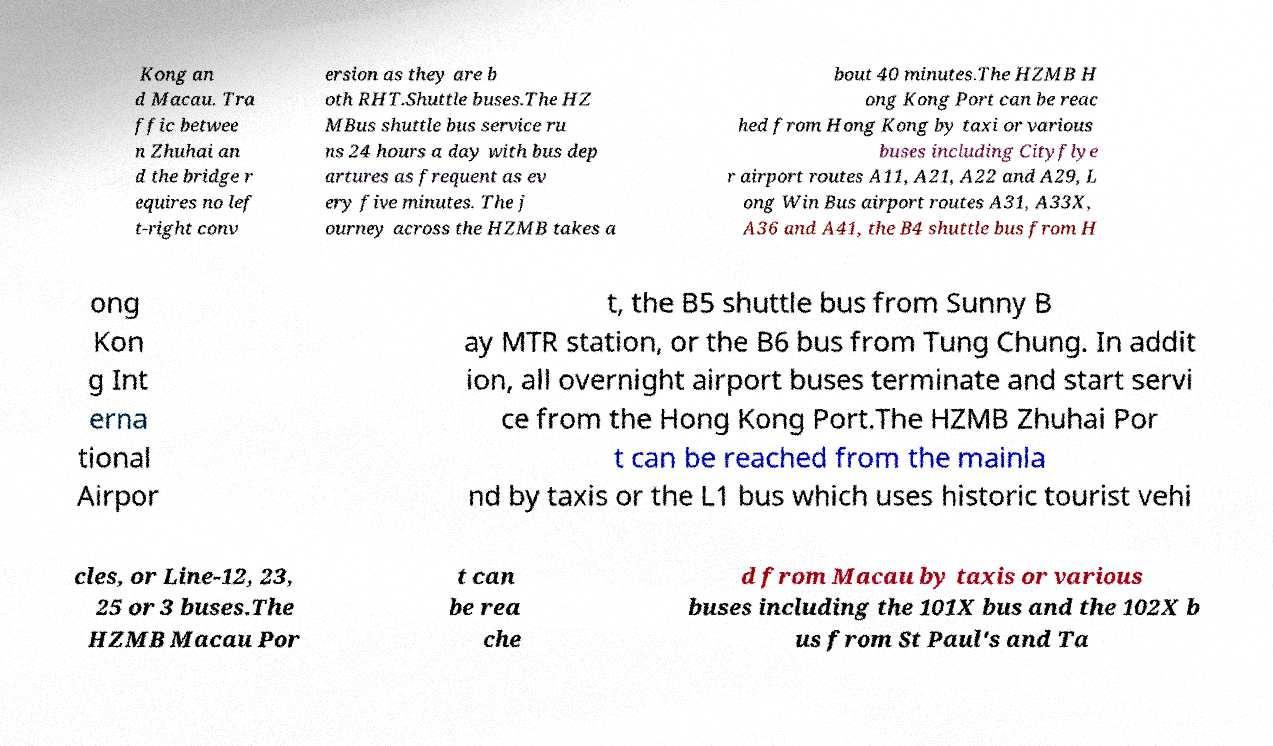Please identify and transcribe the text found in this image. Kong an d Macau. Tra ffic betwee n Zhuhai an d the bridge r equires no lef t-right conv ersion as they are b oth RHT.Shuttle buses.The HZ MBus shuttle bus service ru ns 24 hours a day with bus dep artures as frequent as ev ery five minutes. The j ourney across the HZMB takes a bout 40 minutes.The HZMB H ong Kong Port can be reac hed from Hong Kong by taxi or various buses including Cityflye r airport routes A11, A21, A22 and A29, L ong Win Bus airport routes A31, A33X, A36 and A41, the B4 shuttle bus from H ong Kon g Int erna tional Airpor t, the B5 shuttle bus from Sunny B ay MTR station, or the B6 bus from Tung Chung. In addit ion, all overnight airport buses terminate and start servi ce from the Hong Kong Port.The HZMB Zhuhai Por t can be reached from the mainla nd by taxis or the L1 bus which uses historic tourist vehi cles, or Line-12, 23, 25 or 3 buses.The HZMB Macau Por t can be rea che d from Macau by taxis or various buses including the 101X bus and the 102X b us from St Paul's and Ta 